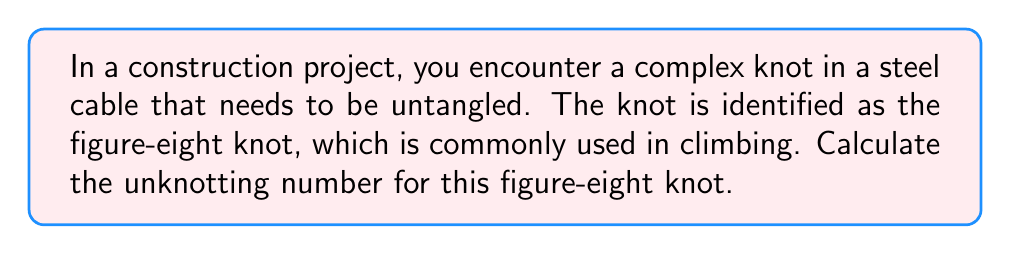What is the answer to this math problem? To calculate the unknotting number for the figure-eight knot, we'll follow these steps:

1. Understand the definition of unknotting number:
   The unknotting number is the minimum number of crossing changes required to transform a given knot into the unknot (trivial knot).

2. Examine the figure-eight knot:
   The figure-eight knot is a prime knot with crossing number 4.

3. Analyze the knot's properties:
   - The figure-eight knot is amphichiral (equivalent to its mirror image).
   - It has a symmetry that allows for efficient unknotting.

4. Determine the minimum crossing changes:
   - One crossing change is not sufficient to unknot the figure-eight knot.
   - Two crossing changes, when done correctly, can unknot it.

5. Verify the unknotting process:
   Consider the following diagram of the figure-eight knot:

   [asy]
   import geometry;

   size(100);
   
   path p = (0,0)..(1,1)..(2,0)..(1,-1)..cycle;
   path q = rotate(90)*p;
   
   draw(p);
   draw(q);
   
   dot((1,1));
   dot((1,-1));
   dot((-1,1));
   dot((-1,-1));
   [/asy]

   By changing the crossings at two opposite points (e.g., top-right and bottom-left), we can transform this into the unknot.

6. Conclude:
   The unknotting number for the figure-eight knot is 2.

This means that in the context of your construction project, you would need to perform two crossing changes to completely untangle the figure-eight knot in the steel cable.
Answer: 2 